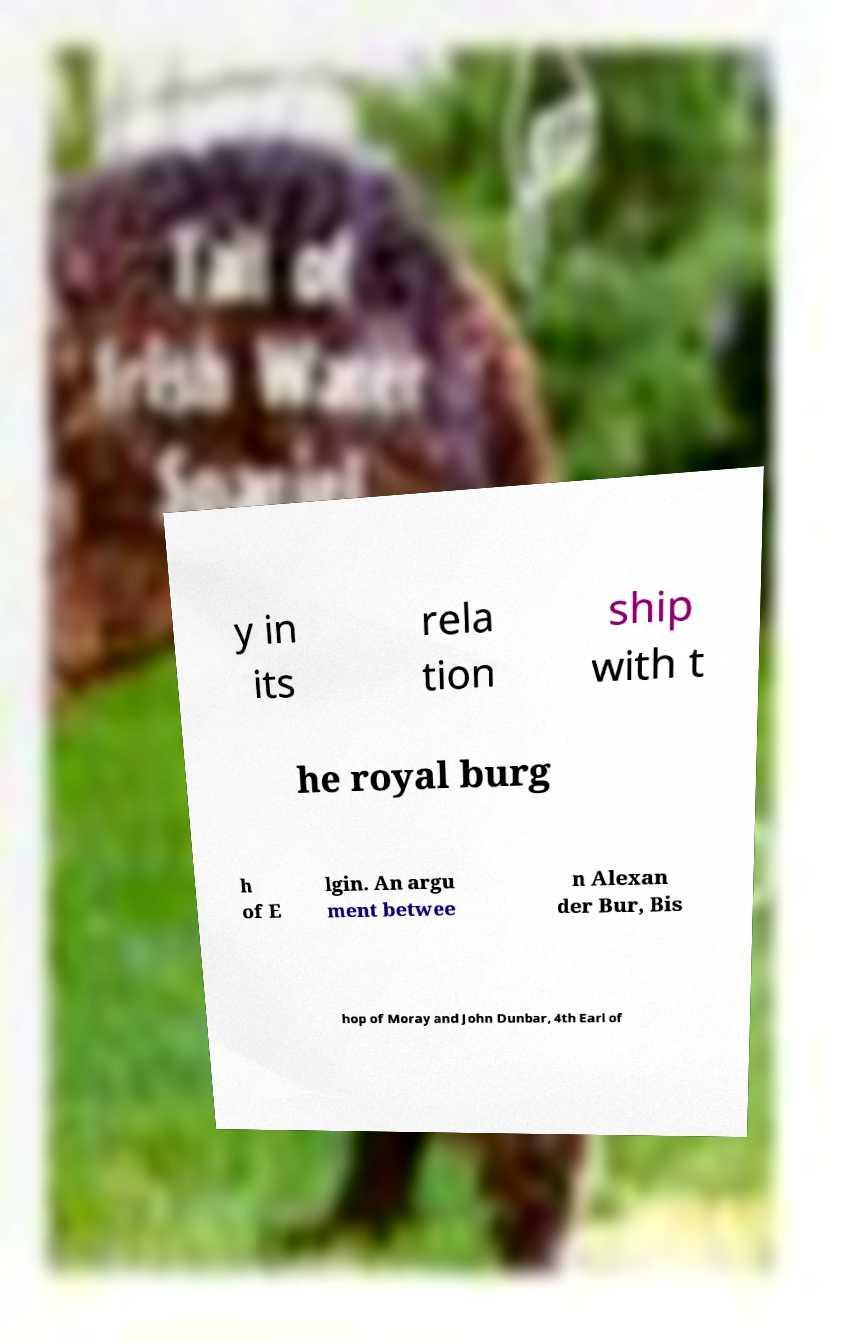I need the written content from this picture converted into text. Can you do that? y in its rela tion ship with t he royal burg h of E lgin. An argu ment betwee n Alexan der Bur, Bis hop of Moray and John Dunbar, 4th Earl of 